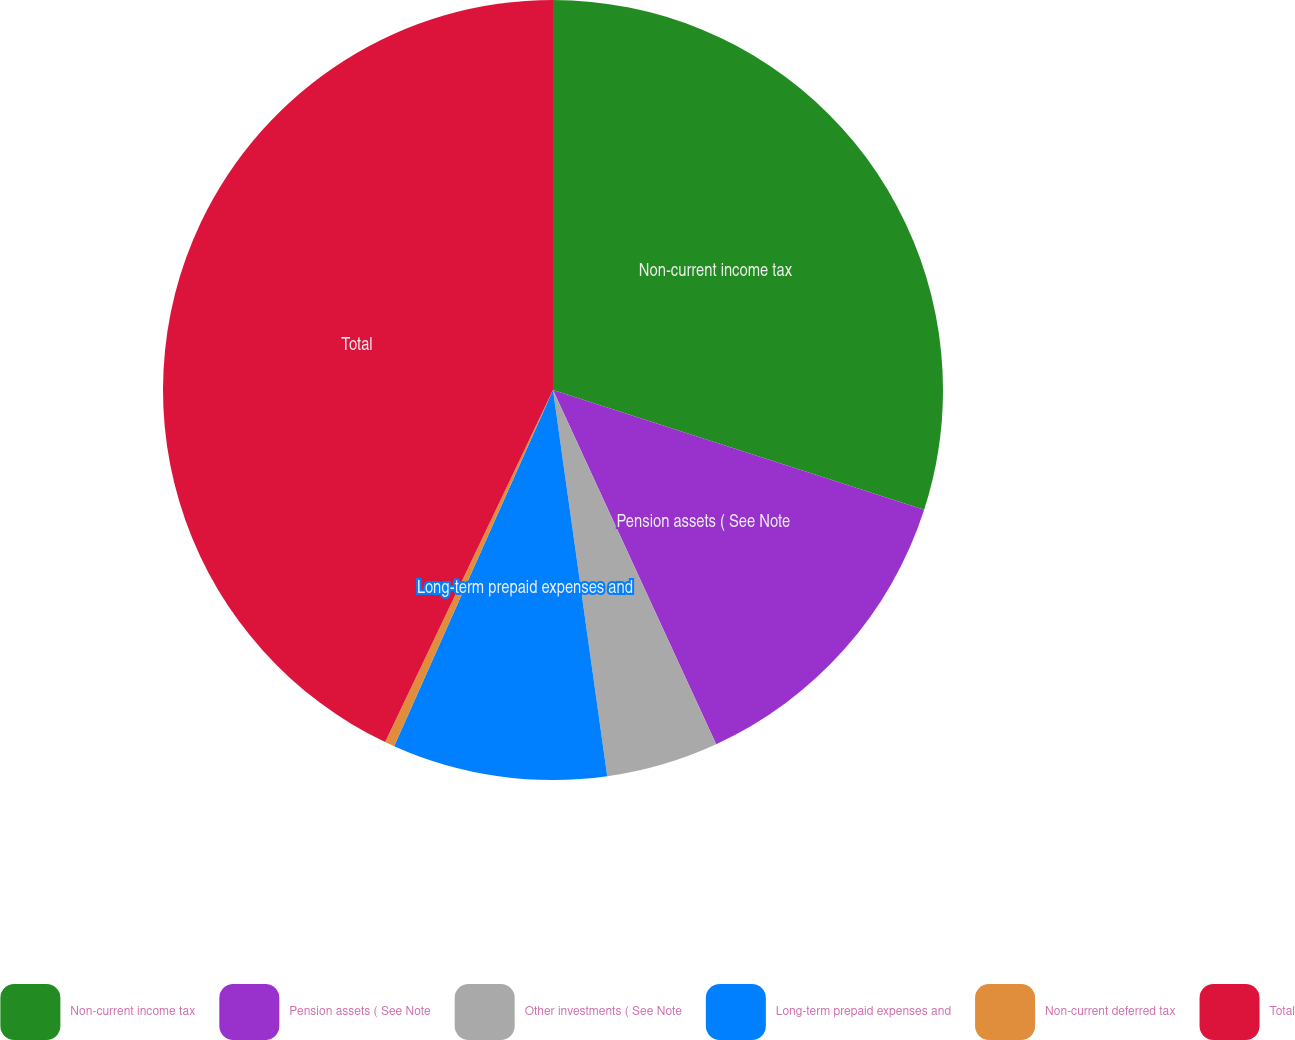Convert chart. <chart><loc_0><loc_0><loc_500><loc_500><pie_chart><fcel>Non-current income tax<fcel>Pension assets ( See Note<fcel>Other investments ( See Note<fcel>Long-term prepaid expenses and<fcel>Non-current deferred tax<fcel>Total<nl><fcel>29.97%<fcel>13.16%<fcel>4.65%<fcel>8.9%<fcel>0.4%<fcel>42.92%<nl></chart> 